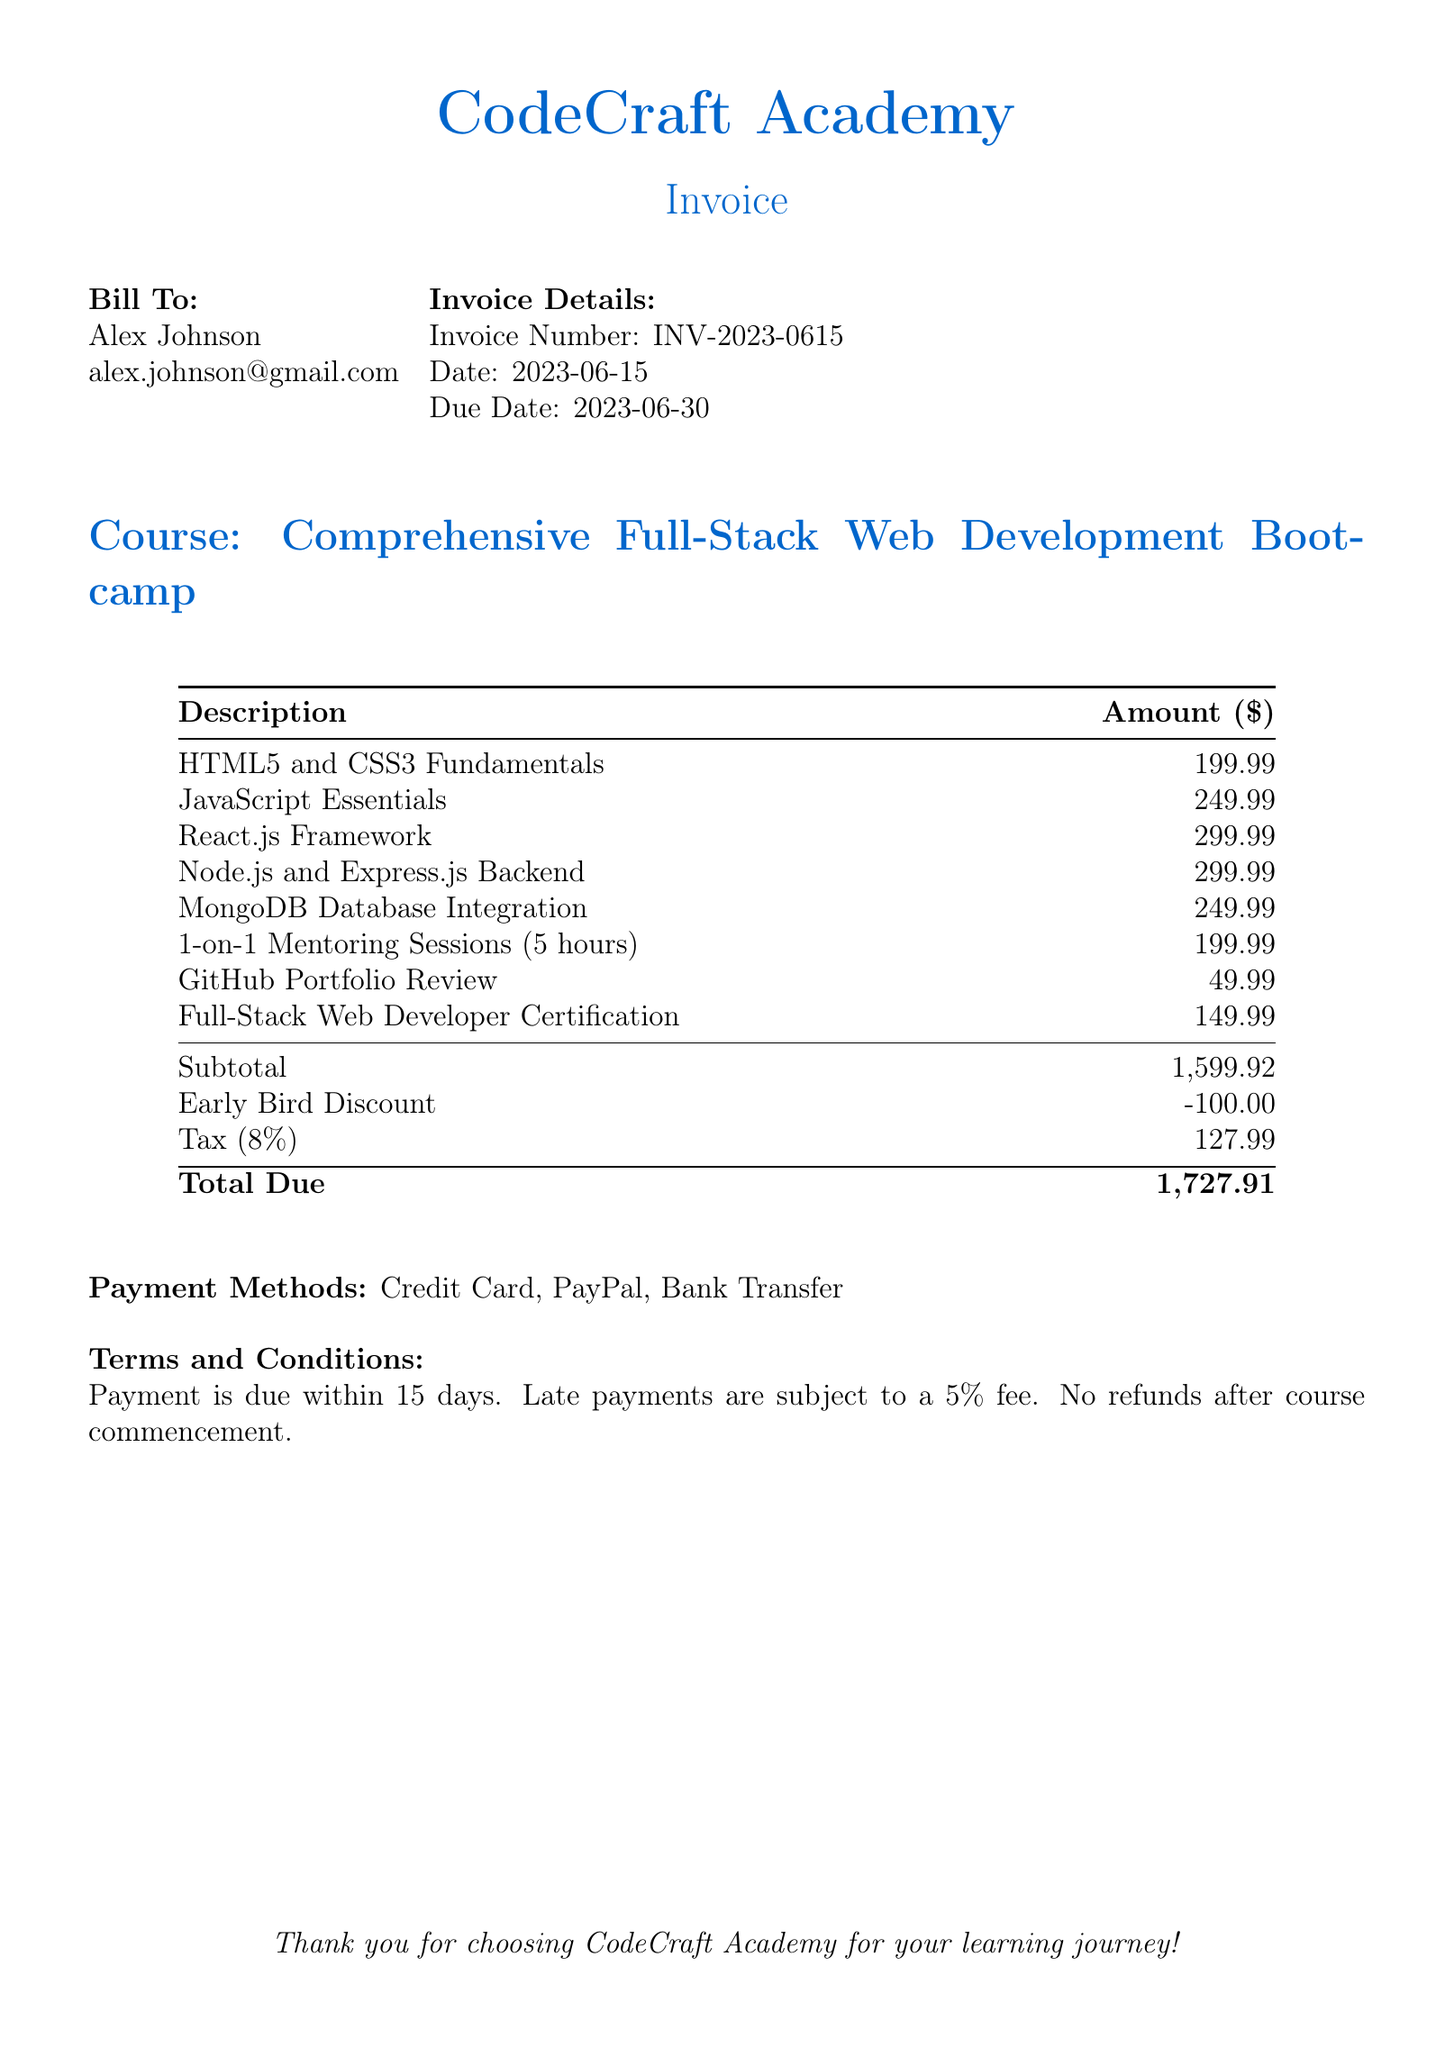What is the invoice number? The invoice number is specified in the invoice details section, which states "Invoice Number: INV-2023-0615."
Answer: INV-2023-0615 What is the total due amount? The total due amount is highlighted in the summary at the bottom of the bill, showing "Total Due: 1,727.91."
Answer: 1,727.91 What is the name of the customer? The customer's name is listed in the "Bill To:" section, which mentions "Alex Johnson."
Answer: Alex Johnson What is the date of the invoice? The date of the invoice is provided in the invoice details section, indicating "Date: 2023-06-15."
Answer: 2023-06-15 How much is the early bird discount? The early bird discount is mentioned in the table, showing "Early Bird Discount: -100.00."
Answer: -100.00 What is the subtotal before tax? The subtotal is specified in the total calculation section as "Subtotal: 1,599.92."
Answer: 1,599.92 What payment methods are accepted? The payment methods are listed at the bottom, stating "Payment Methods: Credit Card, PayPal, Bank Transfer."
Answer: Credit Card, PayPal, Bank Transfer How long do customers have to make the payment? The payment term is outlined under "Terms and Conditions," stating "Payment is due within 15 days."
Answer: 15 days How many mentoring hours are included in the course? The mentoring hours are mentioned in the course description, showing "1-on-1 Mentoring Sessions (5 hours)."
Answer: 5 hours 